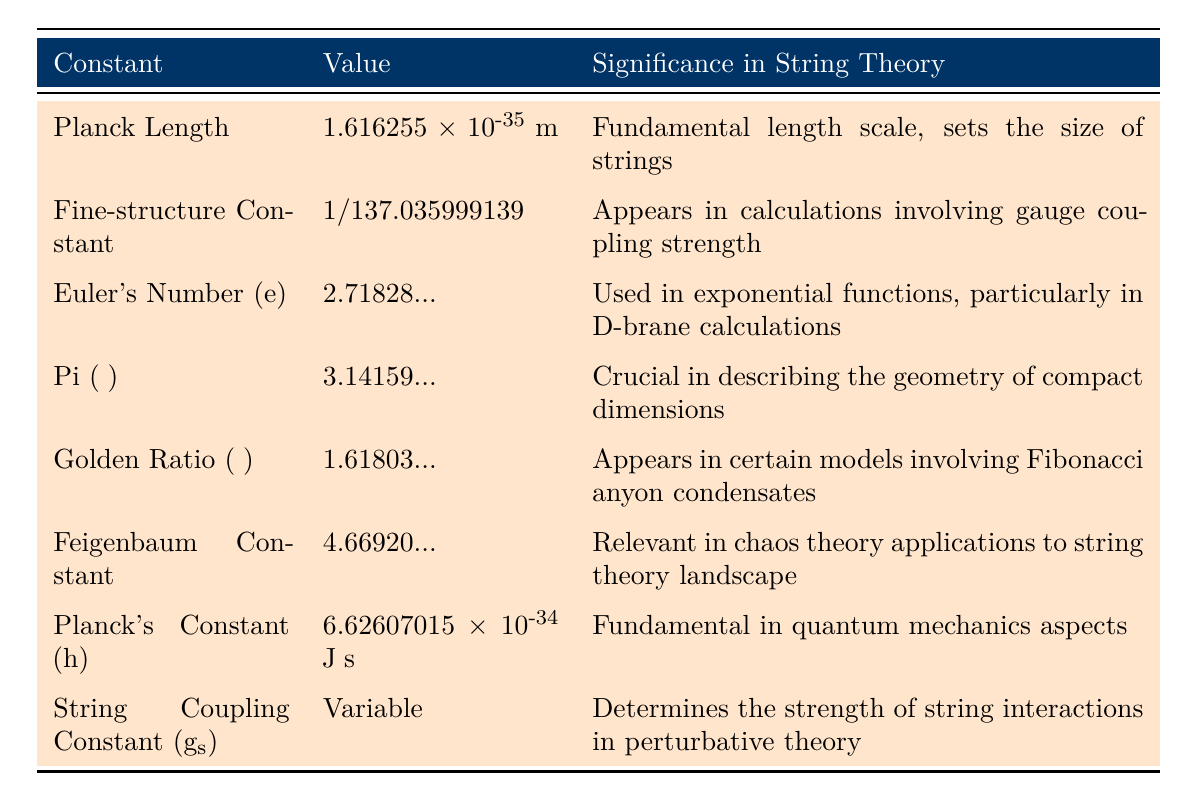What is the value of Planck's Constant? The table lists the value of Planck's Constant (h) as 6.62607015 × 10^-34 J⋅s.
Answer: 6.62607015 × 10^-34 J⋅s Which constant is crucial in describing the geometry of compact dimensions in string theory? According to the table, Pi (π) is crucial in describing the geometry of compact dimensions in string theory.
Answer: Pi (π) Is the Fine-structure Constant represented as a variable? The table specifies that the Fine-structure Constant has the value 1/137.035999139, indicating it is not a variable.
Answer: No What is the significance of Euler's Number (e) in string theory? The table states that Euler's Number (e) is used in exponential functions, particularly in D-brane calculations.
Answer: Used in exponential functions Which mathematical constant appears in models involving Fibonacci anyon condensates? The table indicates that the Golden Ratio (φ) appears in certain string theory models involving Fibonacci anyon condensates.
Answer: Golden Ratio (φ) If you add the values of the Planck Length and Planck's Constant, what kind of physic quantities do they represent? While the numerical addition isn't meaningful due to differing units (meters vs. Joules), both constants are fundamental in theoretical physics; Planck Length sets the scale in string theory and Planck's Constant relates to quantum mechanics.
Answer: Length and quantum How does the String Coupling Constant affect interactions in string theory? The table specifies that the String Coupling Constant (g_s) determines the strength of string interactions in perturbative string theory, which implies its direct influence on interaction dynamics.
Answer: Determines interaction strength What mathematical constant is considered fundamental length scale in string theory? The table shows that the Planck Length is the fundamental length scale in string theory.
Answer: Planck Length Which constant has a value of approximately 4.66920? Referring to the table, the Feigenbaum Constant has a value of approximately 4.66920.
Answer: Feigenbaum Constant Can we conclude that every constant listed has an exact numerical value? The table lists the String Coupling Constant (g_s) as variable, which signifies not every constant has an exact numerical value.
Answer: No Determine a relevant mathematical constant used in calculations of gauge coupling strength. The table clearly states that the Fine-structure Constant is relevant in calculations involving gauge coupling strength in string theory.
Answer: Fine-structure Constant 